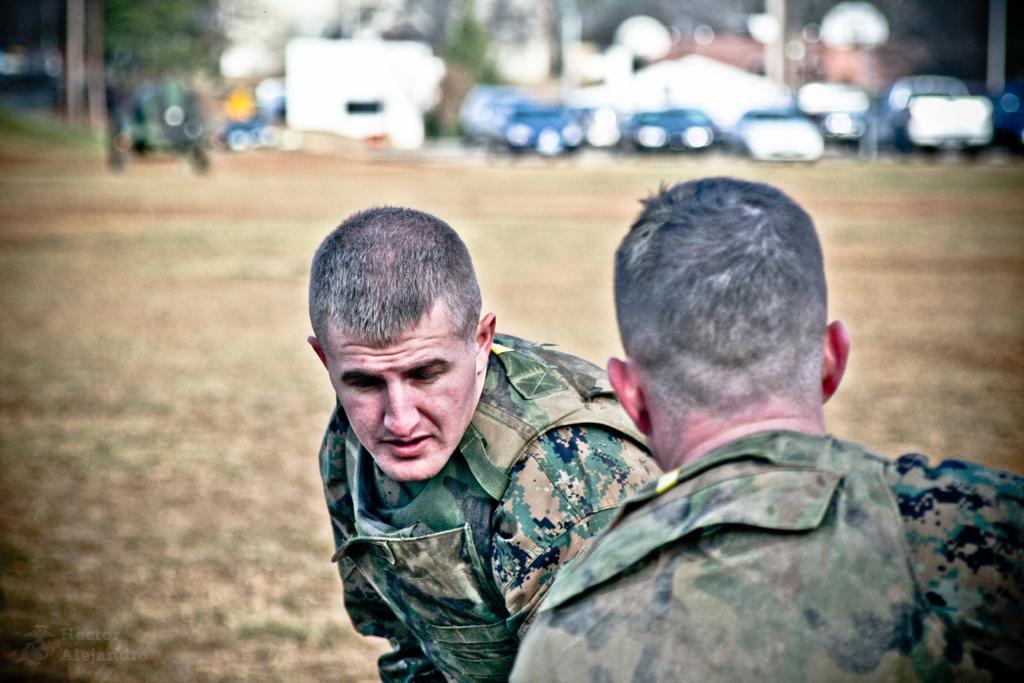Can you describe this image briefly? In this image we can see two people wearing uniforms. In the background there are vehicles and trees. 